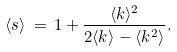<formula> <loc_0><loc_0><loc_500><loc_500>\langle s \rangle \, = \, 1 + \frac { \langle k \rangle ^ { 2 } } { 2 \langle k \rangle - \langle k ^ { 2 } \rangle } .</formula> 